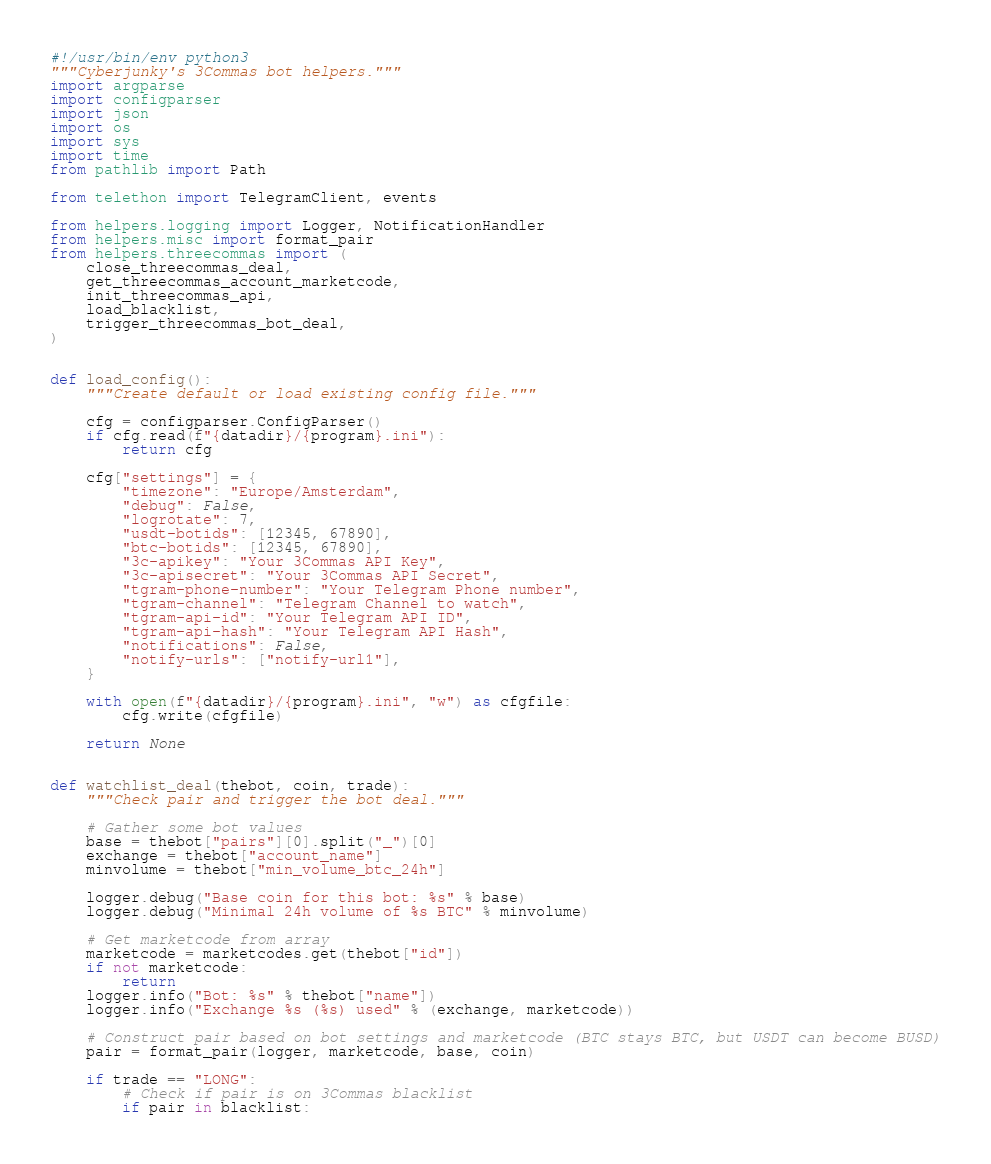Convert code to text. <code><loc_0><loc_0><loc_500><loc_500><_Python_>#!/usr/bin/env python3
"""Cyberjunky's 3Commas bot helpers."""
import argparse
import configparser
import json
import os
import sys
import time
from pathlib import Path

from telethon import TelegramClient, events

from helpers.logging import Logger, NotificationHandler
from helpers.misc import format_pair
from helpers.threecommas import (
    close_threecommas_deal,
    get_threecommas_account_marketcode,
    init_threecommas_api,
    load_blacklist,
    trigger_threecommas_bot_deal,
)


def load_config():
    """Create default or load existing config file."""

    cfg = configparser.ConfigParser()
    if cfg.read(f"{datadir}/{program}.ini"):
        return cfg

    cfg["settings"] = {
        "timezone": "Europe/Amsterdam",
        "debug": False,
        "logrotate": 7,
        "usdt-botids": [12345, 67890],
        "btc-botids": [12345, 67890],
        "3c-apikey": "Your 3Commas API Key",
        "3c-apisecret": "Your 3Commas API Secret",
        "tgram-phone-number": "Your Telegram Phone number",
        "tgram-channel": "Telegram Channel to watch",
        "tgram-api-id": "Your Telegram API ID",
        "tgram-api-hash": "Your Telegram API Hash",
        "notifications": False,
        "notify-urls": ["notify-url1"],
    }

    with open(f"{datadir}/{program}.ini", "w") as cfgfile:
        cfg.write(cfgfile)

    return None


def watchlist_deal(thebot, coin, trade):
    """Check pair and trigger the bot deal."""

    # Gather some bot values
    base = thebot["pairs"][0].split("_")[0]
    exchange = thebot["account_name"]
    minvolume = thebot["min_volume_btc_24h"]

    logger.debug("Base coin for this bot: %s" % base)
    logger.debug("Minimal 24h volume of %s BTC" % minvolume)

    # Get marketcode from array
    marketcode = marketcodes.get(thebot["id"])
    if not marketcode:
        return
    logger.info("Bot: %s" % thebot["name"])
    logger.info("Exchange %s (%s) used" % (exchange, marketcode))

    # Construct pair based on bot settings and marketcode (BTC stays BTC, but USDT can become BUSD)
    pair = format_pair(logger, marketcode, base, coin)

    if trade == "LONG":
        # Check if pair is on 3Commas blacklist
        if pair in blacklist:</code> 